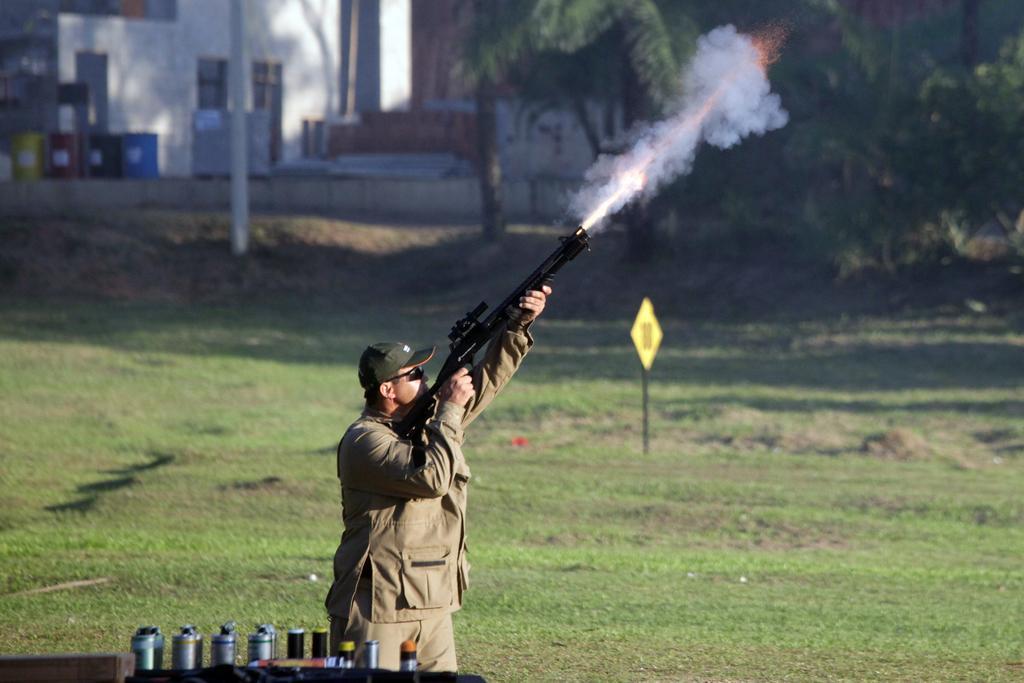Describe this image in one or two sentences. In this image I can see a person holding a gun and the person is wearing brown color dress. Background I can see a board attached to the pole, I can also see few drums in multi color, a building in white color and I can see trees in green color. 